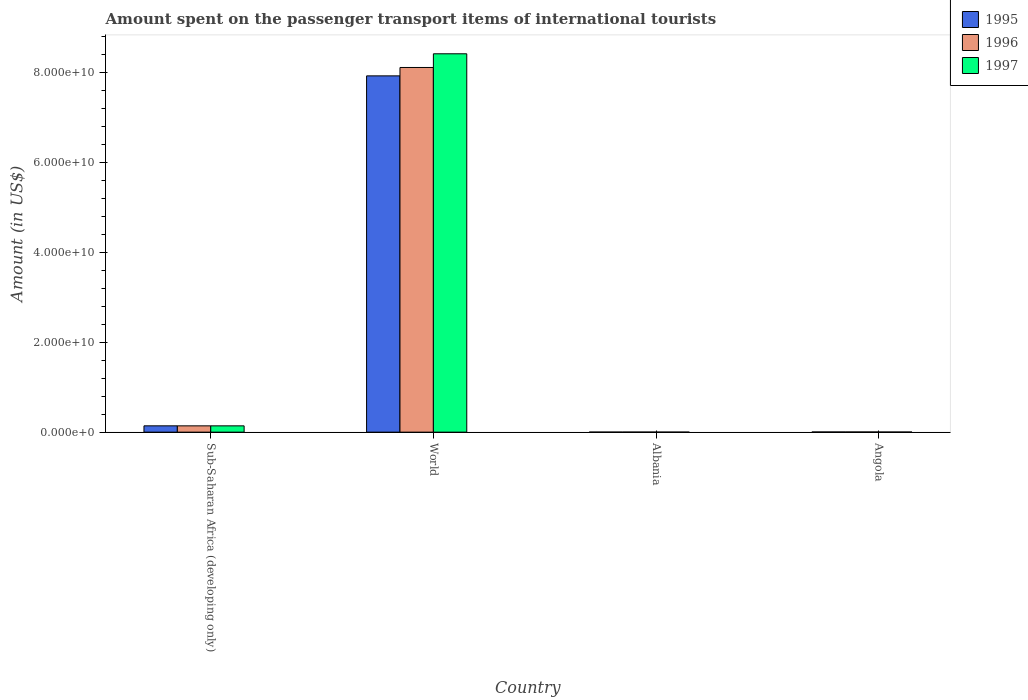How many groups of bars are there?
Provide a short and direct response. 4. How many bars are there on the 2nd tick from the left?
Offer a very short reply. 3. How many bars are there on the 4th tick from the right?
Your response must be concise. 3. What is the label of the 1st group of bars from the left?
Make the answer very short. Sub-Saharan Africa (developing only). In how many cases, is the number of bars for a given country not equal to the number of legend labels?
Your answer should be very brief. 0. What is the amount spent on the passenger transport items of international tourists in 1995 in Angola?
Ensure brevity in your answer.  3.78e+07. Across all countries, what is the maximum amount spent on the passenger transport items of international tourists in 1995?
Offer a terse response. 7.93e+1. Across all countries, what is the minimum amount spent on the passenger transport items of international tourists in 1995?
Provide a succinct answer. 1.20e+07. In which country was the amount spent on the passenger transport items of international tourists in 1997 minimum?
Give a very brief answer. Albania. What is the total amount spent on the passenger transport items of international tourists in 1995 in the graph?
Provide a short and direct response. 8.07e+1. What is the difference between the amount spent on the passenger transport items of international tourists in 1996 in Albania and that in Sub-Saharan Africa (developing only)?
Offer a terse response. -1.39e+09. What is the difference between the amount spent on the passenger transport items of international tourists in 1995 in World and the amount spent on the passenger transport items of international tourists in 1996 in Sub-Saharan Africa (developing only)?
Ensure brevity in your answer.  7.79e+1. What is the average amount spent on the passenger transport items of international tourists in 1996 per country?
Your response must be concise. 2.06e+1. What is the difference between the amount spent on the passenger transport items of international tourists of/in 1997 and amount spent on the passenger transport items of international tourists of/in 1995 in Angola?
Your answer should be compact. -1.06e+07. What is the ratio of the amount spent on the passenger transport items of international tourists in 1995 in Angola to that in World?
Provide a short and direct response. 0. What is the difference between the highest and the second highest amount spent on the passenger transport items of international tourists in 1997?
Offer a very short reply. -8.41e+1. What is the difference between the highest and the lowest amount spent on the passenger transport items of international tourists in 1996?
Your answer should be very brief. 8.11e+1. In how many countries, is the amount spent on the passenger transport items of international tourists in 1996 greater than the average amount spent on the passenger transport items of international tourists in 1996 taken over all countries?
Your answer should be very brief. 1. Is the sum of the amount spent on the passenger transport items of international tourists in 1996 in Angola and World greater than the maximum amount spent on the passenger transport items of international tourists in 1997 across all countries?
Provide a succinct answer. No. What does the 3rd bar from the left in World represents?
Ensure brevity in your answer.  1997. What does the 2nd bar from the right in Sub-Saharan Africa (developing only) represents?
Your answer should be compact. 1996. Is it the case that in every country, the sum of the amount spent on the passenger transport items of international tourists in 1996 and amount spent on the passenger transport items of international tourists in 1995 is greater than the amount spent on the passenger transport items of international tourists in 1997?
Make the answer very short. Yes. Are all the bars in the graph horizontal?
Offer a terse response. No. How many countries are there in the graph?
Give a very brief answer. 4. Are the values on the major ticks of Y-axis written in scientific E-notation?
Provide a succinct answer. Yes. Does the graph contain any zero values?
Your answer should be very brief. No. Where does the legend appear in the graph?
Your answer should be compact. Top right. How many legend labels are there?
Give a very brief answer. 3. How are the legend labels stacked?
Your answer should be compact. Vertical. What is the title of the graph?
Provide a succinct answer. Amount spent on the passenger transport items of international tourists. What is the Amount (in US$) in 1995 in Sub-Saharan Africa (developing only)?
Ensure brevity in your answer.  1.41e+09. What is the Amount (in US$) in 1996 in Sub-Saharan Africa (developing only)?
Ensure brevity in your answer.  1.40e+09. What is the Amount (in US$) in 1997 in Sub-Saharan Africa (developing only)?
Your response must be concise. 1.40e+09. What is the Amount (in US$) of 1995 in World?
Ensure brevity in your answer.  7.93e+1. What is the Amount (in US$) in 1996 in World?
Provide a short and direct response. 8.11e+1. What is the Amount (in US$) in 1997 in World?
Make the answer very short. 8.42e+1. What is the Amount (in US$) of 1996 in Albania?
Ensure brevity in your answer.  1.30e+07. What is the Amount (in US$) of 1995 in Angola?
Your answer should be compact. 3.78e+07. What is the Amount (in US$) in 1996 in Angola?
Offer a terse response. 3.74e+07. What is the Amount (in US$) of 1997 in Angola?
Provide a short and direct response. 2.72e+07. Across all countries, what is the maximum Amount (in US$) of 1995?
Provide a short and direct response. 7.93e+1. Across all countries, what is the maximum Amount (in US$) in 1996?
Your response must be concise. 8.11e+1. Across all countries, what is the maximum Amount (in US$) in 1997?
Make the answer very short. 8.42e+1. Across all countries, what is the minimum Amount (in US$) in 1995?
Give a very brief answer. 1.20e+07. Across all countries, what is the minimum Amount (in US$) in 1996?
Ensure brevity in your answer.  1.30e+07. Across all countries, what is the minimum Amount (in US$) of 1997?
Give a very brief answer. 8.00e+06. What is the total Amount (in US$) of 1995 in the graph?
Make the answer very short. 8.07e+1. What is the total Amount (in US$) in 1996 in the graph?
Give a very brief answer. 8.26e+1. What is the total Amount (in US$) in 1997 in the graph?
Give a very brief answer. 8.56e+1. What is the difference between the Amount (in US$) in 1995 in Sub-Saharan Africa (developing only) and that in World?
Give a very brief answer. -7.78e+1. What is the difference between the Amount (in US$) in 1996 in Sub-Saharan Africa (developing only) and that in World?
Offer a very short reply. -7.97e+1. What is the difference between the Amount (in US$) of 1997 in Sub-Saharan Africa (developing only) and that in World?
Ensure brevity in your answer.  -8.28e+1. What is the difference between the Amount (in US$) in 1995 in Sub-Saharan Africa (developing only) and that in Albania?
Your answer should be very brief. 1.39e+09. What is the difference between the Amount (in US$) in 1996 in Sub-Saharan Africa (developing only) and that in Albania?
Your answer should be very brief. 1.39e+09. What is the difference between the Amount (in US$) in 1997 in Sub-Saharan Africa (developing only) and that in Albania?
Give a very brief answer. 1.39e+09. What is the difference between the Amount (in US$) of 1995 in Sub-Saharan Africa (developing only) and that in Angola?
Offer a very short reply. 1.37e+09. What is the difference between the Amount (in US$) in 1996 in Sub-Saharan Africa (developing only) and that in Angola?
Make the answer very short. 1.36e+09. What is the difference between the Amount (in US$) in 1997 in Sub-Saharan Africa (developing only) and that in Angola?
Offer a very short reply. 1.37e+09. What is the difference between the Amount (in US$) of 1995 in World and that in Albania?
Provide a succinct answer. 7.92e+1. What is the difference between the Amount (in US$) in 1996 in World and that in Albania?
Your response must be concise. 8.11e+1. What is the difference between the Amount (in US$) of 1997 in World and that in Albania?
Offer a very short reply. 8.42e+1. What is the difference between the Amount (in US$) of 1995 in World and that in Angola?
Give a very brief answer. 7.92e+1. What is the difference between the Amount (in US$) in 1996 in World and that in Angola?
Provide a short and direct response. 8.11e+1. What is the difference between the Amount (in US$) in 1997 in World and that in Angola?
Keep it short and to the point. 8.41e+1. What is the difference between the Amount (in US$) of 1995 in Albania and that in Angola?
Your response must be concise. -2.58e+07. What is the difference between the Amount (in US$) in 1996 in Albania and that in Angola?
Your answer should be compact. -2.44e+07. What is the difference between the Amount (in US$) of 1997 in Albania and that in Angola?
Offer a very short reply. -1.92e+07. What is the difference between the Amount (in US$) in 1995 in Sub-Saharan Africa (developing only) and the Amount (in US$) in 1996 in World?
Give a very brief answer. -7.97e+1. What is the difference between the Amount (in US$) in 1995 in Sub-Saharan Africa (developing only) and the Amount (in US$) in 1997 in World?
Provide a succinct answer. -8.28e+1. What is the difference between the Amount (in US$) in 1996 in Sub-Saharan Africa (developing only) and the Amount (in US$) in 1997 in World?
Your response must be concise. -8.28e+1. What is the difference between the Amount (in US$) in 1995 in Sub-Saharan Africa (developing only) and the Amount (in US$) in 1996 in Albania?
Give a very brief answer. 1.39e+09. What is the difference between the Amount (in US$) in 1995 in Sub-Saharan Africa (developing only) and the Amount (in US$) in 1997 in Albania?
Give a very brief answer. 1.40e+09. What is the difference between the Amount (in US$) of 1996 in Sub-Saharan Africa (developing only) and the Amount (in US$) of 1997 in Albania?
Provide a short and direct response. 1.39e+09. What is the difference between the Amount (in US$) of 1995 in Sub-Saharan Africa (developing only) and the Amount (in US$) of 1996 in Angola?
Give a very brief answer. 1.37e+09. What is the difference between the Amount (in US$) in 1995 in Sub-Saharan Africa (developing only) and the Amount (in US$) in 1997 in Angola?
Provide a short and direct response. 1.38e+09. What is the difference between the Amount (in US$) of 1996 in Sub-Saharan Africa (developing only) and the Amount (in US$) of 1997 in Angola?
Ensure brevity in your answer.  1.37e+09. What is the difference between the Amount (in US$) of 1995 in World and the Amount (in US$) of 1996 in Albania?
Provide a succinct answer. 7.92e+1. What is the difference between the Amount (in US$) of 1995 in World and the Amount (in US$) of 1997 in Albania?
Offer a terse response. 7.92e+1. What is the difference between the Amount (in US$) in 1996 in World and the Amount (in US$) in 1997 in Albania?
Give a very brief answer. 8.11e+1. What is the difference between the Amount (in US$) of 1995 in World and the Amount (in US$) of 1996 in Angola?
Your answer should be very brief. 7.92e+1. What is the difference between the Amount (in US$) in 1995 in World and the Amount (in US$) in 1997 in Angola?
Give a very brief answer. 7.92e+1. What is the difference between the Amount (in US$) of 1996 in World and the Amount (in US$) of 1997 in Angola?
Provide a succinct answer. 8.11e+1. What is the difference between the Amount (in US$) of 1995 in Albania and the Amount (in US$) of 1996 in Angola?
Your answer should be compact. -2.54e+07. What is the difference between the Amount (in US$) in 1995 in Albania and the Amount (in US$) in 1997 in Angola?
Your response must be concise. -1.52e+07. What is the difference between the Amount (in US$) in 1996 in Albania and the Amount (in US$) in 1997 in Angola?
Your response must be concise. -1.42e+07. What is the average Amount (in US$) in 1995 per country?
Provide a short and direct response. 2.02e+1. What is the average Amount (in US$) in 1996 per country?
Provide a succinct answer. 2.06e+1. What is the average Amount (in US$) of 1997 per country?
Provide a short and direct response. 2.14e+1. What is the difference between the Amount (in US$) in 1995 and Amount (in US$) in 1996 in Sub-Saharan Africa (developing only)?
Your answer should be very brief. 6.01e+06. What is the difference between the Amount (in US$) in 1995 and Amount (in US$) in 1997 in Sub-Saharan Africa (developing only)?
Keep it short and to the point. 3.52e+06. What is the difference between the Amount (in US$) in 1996 and Amount (in US$) in 1997 in Sub-Saharan Africa (developing only)?
Your answer should be very brief. -2.49e+06. What is the difference between the Amount (in US$) in 1995 and Amount (in US$) in 1996 in World?
Offer a very short reply. -1.87e+09. What is the difference between the Amount (in US$) of 1995 and Amount (in US$) of 1997 in World?
Offer a terse response. -4.91e+09. What is the difference between the Amount (in US$) in 1996 and Amount (in US$) in 1997 in World?
Ensure brevity in your answer.  -3.04e+09. What is the difference between the Amount (in US$) of 1995 and Amount (in US$) of 1996 in Albania?
Make the answer very short. -1.00e+06. What is the difference between the Amount (in US$) in 1995 and Amount (in US$) in 1997 in Albania?
Your answer should be compact. 4.00e+06. What is the difference between the Amount (in US$) in 1995 and Amount (in US$) in 1996 in Angola?
Your answer should be compact. 4.50e+05. What is the difference between the Amount (in US$) of 1995 and Amount (in US$) of 1997 in Angola?
Keep it short and to the point. 1.06e+07. What is the difference between the Amount (in US$) in 1996 and Amount (in US$) in 1997 in Angola?
Your answer should be compact. 1.02e+07. What is the ratio of the Amount (in US$) of 1995 in Sub-Saharan Africa (developing only) to that in World?
Provide a short and direct response. 0.02. What is the ratio of the Amount (in US$) in 1996 in Sub-Saharan Africa (developing only) to that in World?
Ensure brevity in your answer.  0.02. What is the ratio of the Amount (in US$) of 1997 in Sub-Saharan Africa (developing only) to that in World?
Provide a short and direct response. 0.02. What is the ratio of the Amount (in US$) of 1995 in Sub-Saharan Africa (developing only) to that in Albania?
Offer a terse response. 117.11. What is the ratio of the Amount (in US$) in 1996 in Sub-Saharan Africa (developing only) to that in Albania?
Make the answer very short. 107.64. What is the ratio of the Amount (in US$) in 1997 in Sub-Saharan Africa (developing only) to that in Albania?
Ensure brevity in your answer.  175.23. What is the ratio of the Amount (in US$) of 1995 in Sub-Saharan Africa (developing only) to that in Angola?
Give a very brief answer. 37.16. What is the ratio of the Amount (in US$) in 1996 in Sub-Saharan Africa (developing only) to that in Angola?
Give a very brief answer. 37.45. What is the ratio of the Amount (in US$) of 1997 in Sub-Saharan Africa (developing only) to that in Angola?
Provide a succinct answer. 51.54. What is the ratio of the Amount (in US$) in 1995 in World to that in Albania?
Offer a terse response. 6604.42. What is the ratio of the Amount (in US$) in 1996 in World to that in Albania?
Provide a short and direct response. 6239.88. What is the ratio of the Amount (in US$) of 1997 in World to that in Albania?
Your answer should be compact. 1.05e+04. What is the ratio of the Amount (in US$) of 1995 in World to that in Angola?
Provide a short and direct response. 2095.59. What is the ratio of the Amount (in US$) in 1996 in World to that in Angola?
Your answer should be compact. 2170.74. What is the ratio of the Amount (in US$) in 1997 in World to that in Angola?
Keep it short and to the point. 3094.22. What is the ratio of the Amount (in US$) in 1995 in Albania to that in Angola?
Offer a very short reply. 0.32. What is the ratio of the Amount (in US$) of 1996 in Albania to that in Angola?
Provide a short and direct response. 0.35. What is the ratio of the Amount (in US$) of 1997 in Albania to that in Angola?
Give a very brief answer. 0.29. What is the difference between the highest and the second highest Amount (in US$) in 1995?
Your answer should be very brief. 7.78e+1. What is the difference between the highest and the second highest Amount (in US$) in 1996?
Offer a very short reply. 7.97e+1. What is the difference between the highest and the second highest Amount (in US$) of 1997?
Your answer should be compact. 8.28e+1. What is the difference between the highest and the lowest Amount (in US$) of 1995?
Keep it short and to the point. 7.92e+1. What is the difference between the highest and the lowest Amount (in US$) of 1996?
Your answer should be very brief. 8.11e+1. What is the difference between the highest and the lowest Amount (in US$) of 1997?
Make the answer very short. 8.42e+1. 